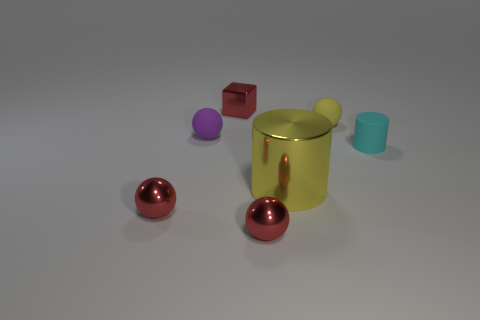There is a yellow object that is behind the big shiny cylinder; is its size the same as the cylinder that is in front of the small cyan matte cylinder?
Offer a very short reply. No. What color is the tiny matte ball on the left side of the matte ball behind the small purple matte thing?
Give a very brief answer. Purple. There is a red cube that is the same size as the cyan matte cylinder; what is it made of?
Provide a succinct answer. Metal. How many rubber things are either small yellow objects or spheres?
Keep it short and to the point. 2. There is a matte object that is both right of the purple ball and in front of the tiny yellow rubber thing; what color is it?
Provide a succinct answer. Cyan. There is a cube; what number of tiny things are on the right side of it?
Offer a very short reply. 3. What material is the small cube?
Provide a succinct answer. Metal. There is a ball that is on the right side of the shiny ball on the right side of the tiny red metallic object that is behind the small yellow thing; what is its color?
Give a very brief answer. Yellow. What number of rubber objects are the same size as the matte cylinder?
Keep it short and to the point. 2. The tiny rubber sphere to the right of the large metallic cylinder is what color?
Provide a short and direct response. Yellow. 